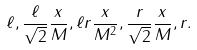Convert formula to latex. <formula><loc_0><loc_0><loc_500><loc_500>\ell , \frac { \ell } { \sqrt { 2 } } \frac { x } { M } , \ell r \frac { x } { M ^ { 2 } } , \frac { r } { \sqrt { 2 } } \frac { x } { M } , r .</formula> 